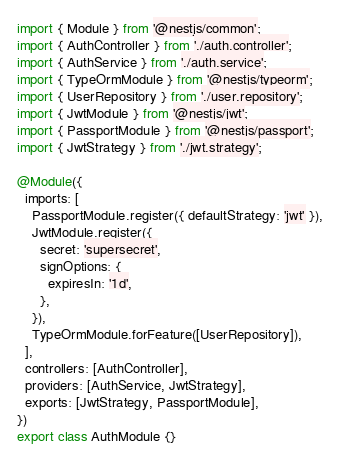<code> <loc_0><loc_0><loc_500><loc_500><_TypeScript_>import { Module } from '@nestjs/common';
import { AuthController } from './auth.controller';
import { AuthService } from './auth.service';
import { TypeOrmModule } from '@nestjs/typeorm';
import { UserRepository } from './user.repository';
import { JwtModule } from '@nestjs/jwt';
import { PassportModule } from '@nestjs/passport';
import { JwtStrategy } from './jwt.strategy';

@Module({
  imports: [
    PassportModule.register({ defaultStrategy: 'jwt' }),
    JwtModule.register({
      secret: 'supersecret',
      signOptions: {
        expiresIn: '1d',
      },
    }),
    TypeOrmModule.forFeature([UserRepository]),
  ],
  controllers: [AuthController],
  providers: [AuthService, JwtStrategy],
  exports: [JwtStrategy, PassportModule],
})
export class AuthModule {}
</code> 